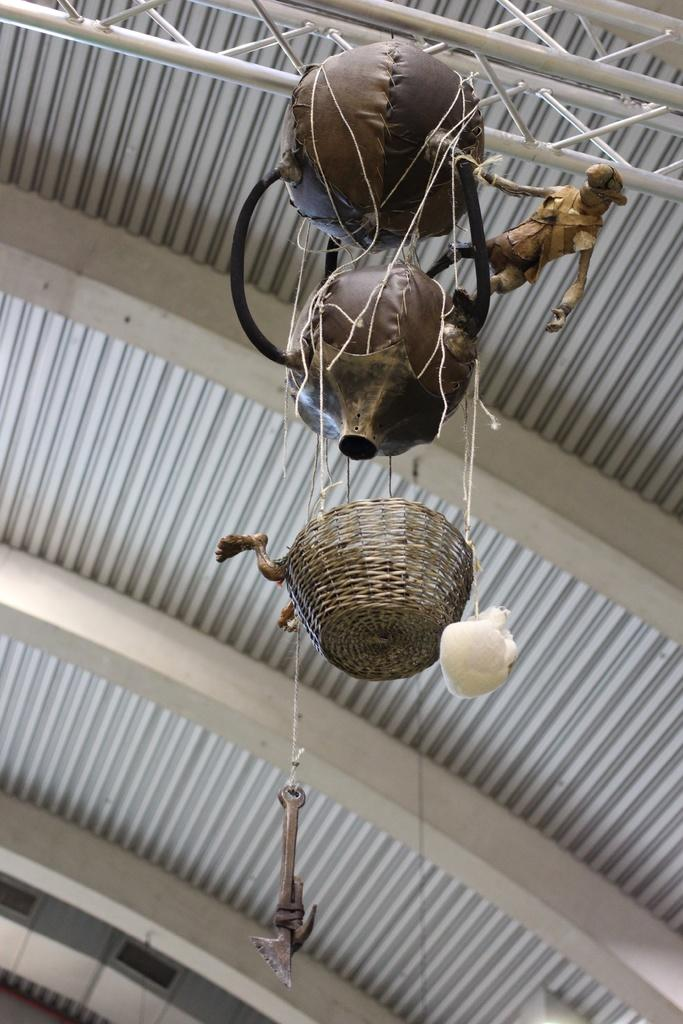What can be found in the middle of the image? There are decorative things in the middle of the image. What type of material is used for the objects at the top of the image? The objects at the top of the image are made of metal rods. What can be seen in the background of the image? There appear to be metal sheets in the background of the image. Is there a farmer standing next to the decorative things in the image? There is no farmer present in the image. What type of door can be seen in the image? There is no door visible in the image. 